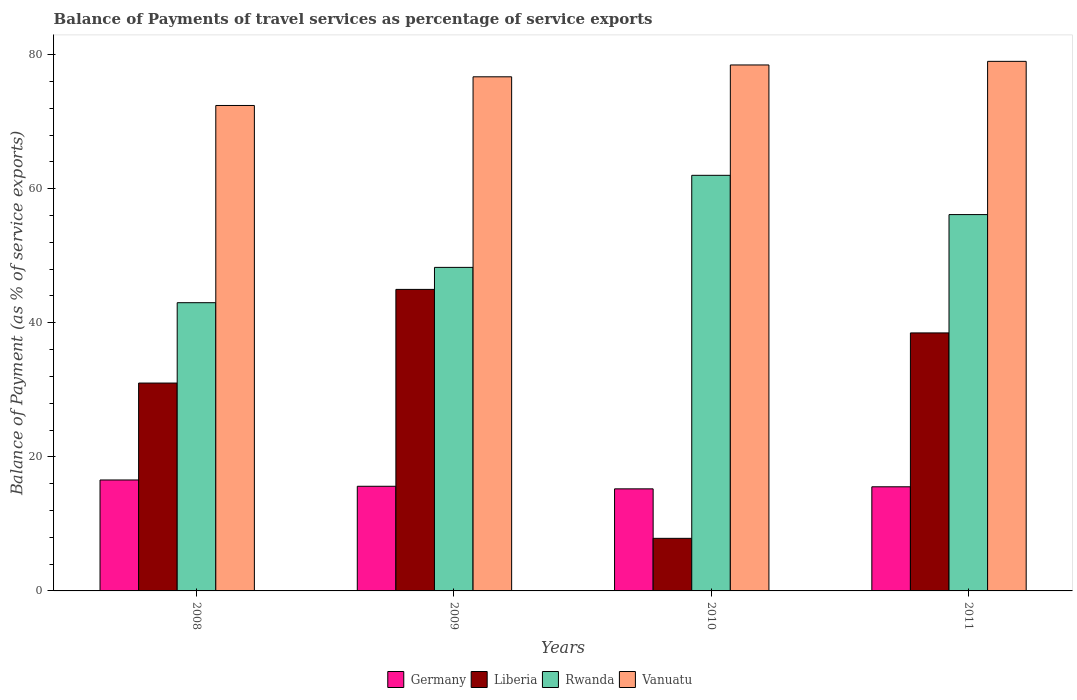How many different coloured bars are there?
Keep it short and to the point. 4. Are the number of bars on each tick of the X-axis equal?
Ensure brevity in your answer.  Yes. In how many cases, is the number of bars for a given year not equal to the number of legend labels?
Offer a very short reply. 0. What is the balance of payments of travel services in Germany in 2009?
Ensure brevity in your answer.  15.61. Across all years, what is the maximum balance of payments of travel services in Liberia?
Provide a short and direct response. 44.98. Across all years, what is the minimum balance of payments of travel services in Rwanda?
Your response must be concise. 42.99. What is the total balance of payments of travel services in Liberia in the graph?
Provide a short and direct response. 122.32. What is the difference between the balance of payments of travel services in Rwanda in 2009 and that in 2010?
Offer a very short reply. -13.73. What is the difference between the balance of payments of travel services in Vanuatu in 2008 and the balance of payments of travel services in Rwanda in 2011?
Your answer should be compact. 16.28. What is the average balance of payments of travel services in Liberia per year?
Offer a very short reply. 30.58. In the year 2008, what is the difference between the balance of payments of travel services in Vanuatu and balance of payments of travel services in Rwanda?
Make the answer very short. 29.42. What is the ratio of the balance of payments of travel services in Vanuatu in 2009 to that in 2010?
Offer a terse response. 0.98. Is the balance of payments of travel services in Rwanda in 2009 less than that in 2010?
Your answer should be compact. Yes. What is the difference between the highest and the second highest balance of payments of travel services in Liberia?
Make the answer very short. 6.49. What is the difference between the highest and the lowest balance of payments of travel services in Germany?
Give a very brief answer. 1.32. In how many years, is the balance of payments of travel services in Vanuatu greater than the average balance of payments of travel services in Vanuatu taken over all years?
Give a very brief answer. 3. Is the sum of the balance of payments of travel services in Rwanda in 2010 and 2011 greater than the maximum balance of payments of travel services in Germany across all years?
Provide a short and direct response. Yes. Is it the case that in every year, the sum of the balance of payments of travel services in Germany and balance of payments of travel services in Vanuatu is greater than the sum of balance of payments of travel services in Rwanda and balance of payments of travel services in Liberia?
Your answer should be very brief. No. What does the 4th bar from the left in 2008 represents?
Offer a terse response. Vanuatu. What does the 4th bar from the right in 2010 represents?
Provide a succinct answer. Germany. Is it the case that in every year, the sum of the balance of payments of travel services in Liberia and balance of payments of travel services in Germany is greater than the balance of payments of travel services in Vanuatu?
Offer a terse response. No. How many bars are there?
Your response must be concise. 16. Are all the bars in the graph horizontal?
Offer a terse response. No. What is the difference between two consecutive major ticks on the Y-axis?
Give a very brief answer. 20. Are the values on the major ticks of Y-axis written in scientific E-notation?
Provide a short and direct response. No. Does the graph contain any zero values?
Offer a very short reply. No. Does the graph contain grids?
Give a very brief answer. No. Where does the legend appear in the graph?
Offer a terse response. Bottom center. How many legend labels are there?
Your response must be concise. 4. What is the title of the graph?
Provide a short and direct response. Balance of Payments of travel services as percentage of service exports. What is the label or title of the X-axis?
Give a very brief answer. Years. What is the label or title of the Y-axis?
Ensure brevity in your answer.  Balance of Payment (as % of service exports). What is the Balance of Payment (as % of service exports) in Germany in 2008?
Offer a terse response. 16.55. What is the Balance of Payment (as % of service exports) of Liberia in 2008?
Provide a succinct answer. 31.01. What is the Balance of Payment (as % of service exports) in Rwanda in 2008?
Offer a very short reply. 42.99. What is the Balance of Payment (as % of service exports) in Vanuatu in 2008?
Offer a very short reply. 72.41. What is the Balance of Payment (as % of service exports) in Germany in 2009?
Make the answer very short. 15.61. What is the Balance of Payment (as % of service exports) in Liberia in 2009?
Ensure brevity in your answer.  44.98. What is the Balance of Payment (as % of service exports) of Rwanda in 2009?
Give a very brief answer. 48.26. What is the Balance of Payment (as % of service exports) in Vanuatu in 2009?
Offer a very short reply. 76.69. What is the Balance of Payment (as % of service exports) in Germany in 2010?
Provide a succinct answer. 15.23. What is the Balance of Payment (as % of service exports) in Liberia in 2010?
Your answer should be compact. 7.84. What is the Balance of Payment (as % of service exports) in Rwanda in 2010?
Give a very brief answer. 61.99. What is the Balance of Payment (as % of service exports) of Vanuatu in 2010?
Offer a terse response. 78.46. What is the Balance of Payment (as % of service exports) in Germany in 2011?
Your answer should be very brief. 15.53. What is the Balance of Payment (as % of service exports) in Liberia in 2011?
Ensure brevity in your answer.  38.49. What is the Balance of Payment (as % of service exports) of Rwanda in 2011?
Make the answer very short. 56.14. What is the Balance of Payment (as % of service exports) in Vanuatu in 2011?
Keep it short and to the point. 78.99. Across all years, what is the maximum Balance of Payment (as % of service exports) of Germany?
Provide a succinct answer. 16.55. Across all years, what is the maximum Balance of Payment (as % of service exports) of Liberia?
Make the answer very short. 44.98. Across all years, what is the maximum Balance of Payment (as % of service exports) of Rwanda?
Offer a terse response. 61.99. Across all years, what is the maximum Balance of Payment (as % of service exports) in Vanuatu?
Your answer should be very brief. 78.99. Across all years, what is the minimum Balance of Payment (as % of service exports) of Germany?
Keep it short and to the point. 15.23. Across all years, what is the minimum Balance of Payment (as % of service exports) in Liberia?
Ensure brevity in your answer.  7.84. Across all years, what is the minimum Balance of Payment (as % of service exports) in Rwanda?
Make the answer very short. 42.99. Across all years, what is the minimum Balance of Payment (as % of service exports) in Vanuatu?
Make the answer very short. 72.41. What is the total Balance of Payment (as % of service exports) in Germany in the graph?
Offer a very short reply. 62.92. What is the total Balance of Payment (as % of service exports) of Liberia in the graph?
Offer a very short reply. 122.32. What is the total Balance of Payment (as % of service exports) in Rwanda in the graph?
Your answer should be compact. 209.39. What is the total Balance of Payment (as % of service exports) of Vanuatu in the graph?
Offer a terse response. 306.56. What is the difference between the Balance of Payment (as % of service exports) of Germany in 2008 and that in 2009?
Make the answer very short. 0.94. What is the difference between the Balance of Payment (as % of service exports) in Liberia in 2008 and that in 2009?
Provide a short and direct response. -13.97. What is the difference between the Balance of Payment (as % of service exports) in Rwanda in 2008 and that in 2009?
Offer a very short reply. -5.27. What is the difference between the Balance of Payment (as % of service exports) in Vanuatu in 2008 and that in 2009?
Your answer should be compact. -4.28. What is the difference between the Balance of Payment (as % of service exports) in Germany in 2008 and that in 2010?
Make the answer very short. 1.32. What is the difference between the Balance of Payment (as % of service exports) of Liberia in 2008 and that in 2010?
Offer a very short reply. 23.16. What is the difference between the Balance of Payment (as % of service exports) in Rwanda in 2008 and that in 2010?
Keep it short and to the point. -19. What is the difference between the Balance of Payment (as % of service exports) in Vanuatu in 2008 and that in 2010?
Your response must be concise. -6.04. What is the difference between the Balance of Payment (as % of service exports) of Germany in 2008 and that in 2011?
Ensure brevity in your answer.  1.01. What is the difference between the Balance of Payment (as % of service exports) of Liberia in 2008 and that in 2011?
Your response must be concise. -7.48. What is the difference between the Balance of Payment (as % of service exports) of Rwanda in 2008 and that in 2011?
Provide a short and direct response. -13.14. What is the difference between the Balance of Payment (as % of service exports) in Vanuatu in 2008 and that in 2011?
Your answer should be compact. -6.58. What is the difference between the Balance of Payment (as % of service exports) of Germany in 2009 and that in 2010?
Keep it short and to the point. 0.38. What is the difference between the Balance of Payment (as % of service exports) in Liberia in 2009 and that in 2010?
Your answer should be compact. 37.13. What is the difference between the Balance of Payment (as % of service exports) of Rwanda in 2009 and that in 2010?
Your answer should be very brief. -13.73. What is the difference between the Balance of Payment (as % of service exports) in Vanuatu in 2009 and that in 2010?
Offer a very short reply. -1.77. What is the difference between the Balance of Payment (as % of service exports) in Germany in 2009 and that in 2011?
Keep it short and to the point. 0.08. What is the difference between the Balance of Payment (as % of service exports) in Liberia in 2009 and that in 2011?
Make the answer very short. 6.49. What is the difference between the Balance of Payment (as % of service exports) in Rwanda in 2009 and that in 2011?
Provide a succinct answer. -7.88. What is the difference between the Balance of Payment (as % of service exports) of Vanuatu in 2009 and that in 2011?
Your answer should be compact. -2.3. What is the difference between the Balance of Payment (as % of service exports) in Germany in 2010 and that in 2011?
Give a very brief answer. -0.31. What is the difference between the Balance of Payment (as % of service exports) of Liberia in 2010 and that in 2011?
Your answer should be very brief. -30.64. What is the difference between the Balance of Payment (as % of service exports) of Rwanda in 2010 and that in 2011?
Give a very brief answer. 5.86. What is the difference between the Balance of Payment (as % of service exports) of Vanuatu in 2010 and that in 2011?
Your response must be concise. -0.54. What is the difference between the Balance of Payment (as % of service exports) in Germany in 2008 and the Balance of Payment (as % of service exports) in Liberia in 2009?
Give a very brief answer. -28.43. What is the difference between the Balance of Payment (as % of service exports) in Germany in 2008 and the Balance of Payment (as % of service exports) in Rwanda in 2009?
Make the answer very short. -31.71. What is the difference between the Balance of Payment (as % of service exports) of Germany in 2008 and the Balance of Payment (as % of service exports) of Vanuatu in 2009?
Your answer should be very brief. -60.14. What is the difference between the Balance of Payment (as % of service exports) in Liberia in 2008 and the Balance of Payment (as % of service exports) in Rwanda in 2009?
Offer a terse response. -17.25. What is the difference between the Balance of Payment (as % of service exports) in Liberia in 2008 and the Balance of Payment (as % of service exports) in Vanuatu in 2009?
Your answer should be very brief. -45.68. What is the difference between the Balance of Payment (as % of service exports) in Rwanda in 2008 and the Balance of Payment (as % of service exports) in Vanuatu in 2009?
Offer a terse response. -33.7. What is the difference between the Balance of Payment (as % of service exports) in Germany in 2008 and the Balance of Payment (as % of service exports) in Liberia in 2010?
Give a very brief answer. 8.7. What is the difference between the Balance of Payment (as % of service exports) of Germany in 2008 and the Balance of Payment (as % of service exports) of Rwanda in 2010?
Keep it short and to the point. -45.45. What is the difference between the Balance of Payment (as % of service exports) of Germany in 2008 and the Balance of Payment (as % of service exports) of Vanuatu in 2010?
Make the answer very short. -61.91. What is the difference between the Balance of Payment (as % of service exports) in Liberia in 2008 and the Balance of Payment (as % of service exports) in Rwanda in 2010?
Your answer should be very brief. -30.99. What is the difference between the Balance of Payment (as % of service exports) in Liberia in 2008 and the Balance of Payment (as % of service exports) in Vanuatu in 2010?
Offer a terse response. -47.45. What is the difference between the Balance of Payment (as % of service exports) in Rwanda in 2008 and the Balance of Payment (as % of service exports) in Vanuatu in 2010?
Your answer should be very brief. -35.46. What is the difference between the Balance of Payment (as % of service exports) of Germany in 2008 and the Balance of Payment (as % of service exports) of Liberia in 2011?
Keep it short and to the point. -21.94. What is the difference between the Balance of Payment (as % of service exports) in Germany in 2008 and the Balance of Payment (as % of service exports) in Rwanda in 2011?
Offer a terse response. -39.59. What is the difference between the Balance of Payment (as % of service exports) in Germany in 2008 and the Balance of Payment (as % of service exports) in Vanuatu in 2011?
Make the answer very short. -62.45. What is the difference between the Balance of Payment (as % of service exports) in Liberia in 2008 and the Balance of Payment (as % of service exports) in Rwanda in 2011?
Your response must be concise. -25.13. What is the difference between the Balance of Payment (as % of service exports) of Liberia in 2008 and the Balance of Payment (as % of service exports) of Vanuatu in 2011?
Offer a very short reply. -47.99. What is the difference between the Balance of Payment (as % of service exports) of Rwanda in 2008 and the Balance of Payment (as % of service exports) of Vanuatu in 2011?
Offer a very short reply. -36. What is the difference between the Balance of Payment (as % of service exports) of Germany in 2009 and the Balance of Payment (as % of service exports) of Liberia in 2010?
Your answer should be compact. 7.77. What is the difference between the Balance of Payment (as % of service exports) of Germany in 2009 and the Balance of Payment (as % of service exports) of Rwanda in 2010?
Provide a short and direct response. -46.38. What is the difference between the Balance of Payment (as % of service exports) of Germany in 2009 and the Balance of Payment (as % of service exports) of Vanuatu in 2010?
Provide a short and direct response. -62.85. What is the difference between the Balance of Payment (as % of service exports) in Liberia in 2009 and the Balance of Payment (as % of service exports) in Rwanda in 2010?
Your answer should be compact. -17.02. What is the difference between the Balance of Payment (as % of service exports) of Liberia in 2009 and the Balance of Payment (as % of service exports) of Vanuatu in 2010?
Your answer should be compact. -33.48. What is the difference between the Balance of Payment (as % of service exports) in Rwanda in 2009 and the Balance of Payment (as % of service exports) in Vanuatu in 2010?
Your response must be concise. -30.2. What is the difference between the Balance of Payment (as % of service exports) of Germany in 2009 and the Balance of Payment (as % of service exports) of Liberia in 2011?
Provide a short and direct response. -22.88. What is the difference between the Balance of Payment (as % of service exports) in Germany in 2009 and the Balance of Payment (as % of service exports) in Rwanda in 2011?
Ensure brevity in your answer.  -40.53. What is the difference between the Balance of Payment (as % of service exports) in Germany in 2009 and the Balance of Payment (as % of service exports) in Vanuatu in 2011?
Provide a short and direct response. -63.38. What is the difference between the Balance of Payment (as % of service exports) in Liberia in 2009 and the Balance of Payment (as % of service exports) in Rwanda in 2011?
Provide a short and direct response. -11.16. What is the difference between the Balance of Payment (as % of service exports) in Liberia in 2009 and the Balance of Payment (as % of service exports) in Vanuatu in 2011?
Make the answer very short. -34.02. What is the difference between the Balance of Payment (as % of service exports) in Rwanda in 2009 and the Balance of Payment (as % of service exports) in Vanuatu in 2011?
Ensure brevity in your answer.  -30.73. What is the difference between the Balance of Payment (as % of service exports) of Germany in 2010 and the Balance of Payment (as % of service exports) of Liberia in 2011?
Your answer should be very brief. -23.26. What is the difference between the Balance of Payment (as % of service exports) in Germany in 2010 and the Balance of Payment (as % of service exports) in Rwanda in 2011?
Make the answer very short. -40.91. What is the difference between the Balance of Payment (as % of service exports) in Germany in 2010 and the Balance of Payment (as % of service exports) in Vanuatu in 2011?
Give a very brief answer. -63.77. What is the difference between the Balance of Payment (as % of service exports) of Liberia in 2010 and the Balance of Payment (as % of service exports) of Rwanda in 2011?
Your answer should be compact. -48.29. What is the difference between the Balance of Payment (as % of service exports) of Liberia in 2010 and the Balance of Payment (as % of service exports) of Vanuatu in 2011?
Your answer should be compact. -71.15. What is the difference between the Balance of Payment (as % of service exports) in Rwanda in 2010 and the Balance of Payment (as % of service exports) in Vanuatu in 2011?
Your response must be concise. -17. What is the average Balance of Payment (as % of service exports) of Germany per year?
Give a very brief answer. 15.73. What is the average Balance of Payment (as % of service exports) of Liberia per year?
Offer a very short reply. 30.58. What is the average Balance of Payment (as % of service exports) in Rwanda per year?
Give a very brief answer. 52.35. What is the average Balance of Payment (as % of service exports) of Vanuatu per year?
Ensure brevity in your answer.  76.64. In the year 2008, what is the difference between the Balance of Payment (as % of service exports) in Germany and Balance of Payment (as % of service exports) in Liberia?
Provide a succinct answer. -14.46. In the year 2008, what is the difference between the Balance of Payment (as % of service exports) in Germany and Balance of Payment (as % of service exports) in Rwanda?
Your answer should be compact. -26.45. In the year 2008, what is the difference between the Balance of Payment (as % of service exports) in Germany and Balance of Payment (as % of service exports) in Vanuatu?
Keep it short and to the point. -55.86. In the year 2008, what is the difference between the Balance of Payment (as % of service exports) in Liberia and Balance of Payment (as % of service exports) in Rwanda?
Offer a very short reply. -11.99. In the year 2008, what is the difference between the Balance of Payment (as % of service exports) of Liberia and Balance of Payment (as % of service exports) of Vanuatu?
Offer a very short reply. -41.4. In the year 2008, what is the difference between the Balance of Payment (as % of service exports) in Rwanda and Balance of Payment (as % of service exports) in Vanuatu?
Provide a short and direct response. -29.42. In the year 2009, what is the difference between the Balance of Payment (as % of service exports) of Germany and Balance of Payment (as % of service exports) of Liberia?
Give a very brief answer. -29.37. In the year 2009, what is the difference between the Balance of Payment (as % of service exports) in Germany and Balance of Payment (as % of service exports) in Rwanda?
Your answer should be compact. -32.65. In the year 2009, what is the difference between the Balance of Payment (as % of service exports) of Germany and Balance of Payment (as % of service exports) of Vanuatu?
Your answer should be compact. -61.08. In the year 2009, what is the difference between the Balance of Payment (as % of service exports) of Liberia and Balance of Payment (as % of service exports) of Rwanda?
Give a very brief answer. -3.28. In the year 2009, what is the difference between the Balance of Payment (as % of service exports) in Liberia and Balance of Payment (as % of service exports) in Vanuatu?
Ensure brevity in your answer.  -31.71. In the year 2009, what is the difference between the Balance of Payment (as % of service exports) of Rwanda and Balance of Payment (as % of service exports) of Vanuatu?
Ensure brevity in your answer.  -28.43. In the year 2010, what is the difference between the Balance of Payment (as % of service exports) of Germany and Balance of Payment (as % of service exports) of Liberia?
Keep it short and to the point. 7.38. In the year 2010, what is the difference between the Balance of Payment (as % of service exports) of Germany and Balance of Payment (as % of service exports) of Rwanda?
Your answer should be compact. -46.77. In the year 2010, what is the difference between the Balance of Payment (as % of service exports) of Germany and Balance of Payment (as % of service exports) of Vanuatu?
Make the answer very short. -63.23. In the year 2010, what is the difference between the Balance of Payment (as % of service exports) in Liberia and Balance of Payment (as % of service exports) in Rwanda?
Give a very brief answer. -54.15. In the year 2010, what is the difference between the Balance of Payment (as % of service exports) of Liberia and Balance of Payment (as % of service exports) of Vanuatu?
Offer a terse response. -70.61. In the year 2010, what is the difference between the Balance of Payment (as % of service exports) in Rwanda and Balance of Payment (as % of service exports) in Vanuatu?
Make the answer very short. -16.46. In the year 2011, what is the difference between the Balance of Payment (as % of service exports) of Germany and Balance of Payment (as % of service exports) of Liberia?
Ensure brevity in your answer.  -22.95. In the year 2011, what is the difference between the Balance of Payment (as % of service exports) of Germany and Balance of Payment (as % of service exports) of Rwanda?
Offer a terse response. -40.6. In the year 2011, what is the difference between the Balance of Payment (as % of service exports) in Germany and Balance of Payment (as % of service exports) in Vanuatu?
Make the answer very short. -63.46. In the year 2011, what is the difference between the Balance of Payment (as % of service exports) in Liberia and Balance of Payment (as % of service exports) in Rwanda?
Offer a terse response. -17.65. In the year 2011, what is the difference between the Balance of Payment (as % of service exports) of Liberia and Balance of Payment (as % of service exports) of Vanuatu?
Your answer should be compact. -40.51. In the year 2011, what is the difference between the Balance of Payment (as % of service exports) of Rwanda and Balance of Payment (as % of service exports) of Vanuatu?
Your answer should be very brief. -22.86. What is the ratio of the Balance of Payment (as % of service exports) of Germany in 2008 to that in 2009?
Your answer should be compact. 1.06. What is the ratio of the Balance of Payment (as % of service exports) in Liberia in 2008 to that in 2009?
Ensure brevity in your answer.  0.69. What is the ratio of the Balance of Payment (as % of service exports) in Rwanda in 2008 to that in 2009?
Your response must be concise. 0.89. What is the ratio of the Balance of Payment (as % of service exports) of Vanuatu in 2008 to that in 2009?
Offer a terse response. 0.94. What is the ratio of the Balance of Payment (as % of service exports) of Germany in 2008 to that in 2010?
Ensure brevity in your answer.  1.09. What is the ratio of the Balance of Payment (as % of service exports) of Liberia in 2008 to that in 2010?
Your answer should be compact. 3.95. What is the ratio of the Balance of Payment (as % of service exports) of Rwanda in 2008 to that in 2010?
Your response must be concise. 0.69. What is the ratio of the Balance of Payment (as % of service exports) of Vanuatu in 2008 to that in 2010?
Your response must be concise. 0.92. What is the ratio of the Balance of Payment (as % of service exports) in Germany in 2008 to that in 2011?
Ensure brevity in your answer.  1.07. What is the ratio of the Balance of Payment (as % of service exports) in Liberia in 2008 to that in 2011?
Ensure brevity in your answer.  0.81. What is the ratio of the Balance of Payment (as % of service exports) of Rwanda in 2008 to that in 2011?
Your answer should be very brief. 0.77. What is the ratio of the Balance of Payment (as % of service exports) of Germany in 2009 to that in 2010?
Keep it short and to the point. 1.03. What is the ratio of the Balance of Payment (as % of service exports) of Liberia in 2009 to that in 2010?
Keep it short and to the point. 5.73. What is the ratio of the Balance of Payment (as % of service exports) in Rwanda in 2009 to that in 2010?
Your answer should be compact. 0.78. What is the ratio of the Balance of Payment (as % of service exports) of Vanuatu in 2009 to that in 2010?
Give a very brief answer. 0.98. What is the ratio of the Balance of Payment (as % of service exports) of Liberia in 2009 to that in 2011?
Offer a very short reply. 1.17. What is the ratio of the Balance of Payment (as % of service exports) of Rwanda in 2009 to that in 2011?
Your response must be concise. 0.86. What is the ratio of the Balance of Payment (as % of service exports) in Vanuatu in 2009 to that in 2011?
Provide a succinct answer. 0.97. What is the ratio of the Balance of Payment (as % of service exports) of Germany in 2010 to that in 2011?
Your answer should be compact. 0.98. What is the ratio of the Balance of Payment (as % of service exports) in Liberia in 2010 to that in 2011?
Make the answer very short. 0.2. What is the ratio of the Balance of Payment (as % of service exports) of Rwanda in 2010 to that in 2011?
Give a very brief answer. 1.1. What is the difference between the highest and the second highest Balance of Payment (as % of service exports) in Germany?
Offer a terse response. 0.94. What is the difference between the highest and the second highest Balance of Payment (as % of service exports) of Liberia?
Your response must be concise. 6.49. What is the difference between the highest and the second highest Balance of Payment (as % of service exports) in Rwanda?
Offer a terse response. 5.86. What is the difference between the highest and the second highest Balance of Payment (as % of service exports) of Vanuatu?
Ensure brevity in your answer.  0.54. What is the difference between the highest and the lowest Balance of Payment (as % of service exports) of Germany?
Make the answer very short. 1.32. What is the difference between the highest and the lowest Balance of Payment (as % of service exports) of Liberia?
Give a very brief answer. 37.13. What is the difference between the highest and the lowest Balance of Payment (as % of service exports) of Vanuatu?
Offer a very short reply. 6.58. 